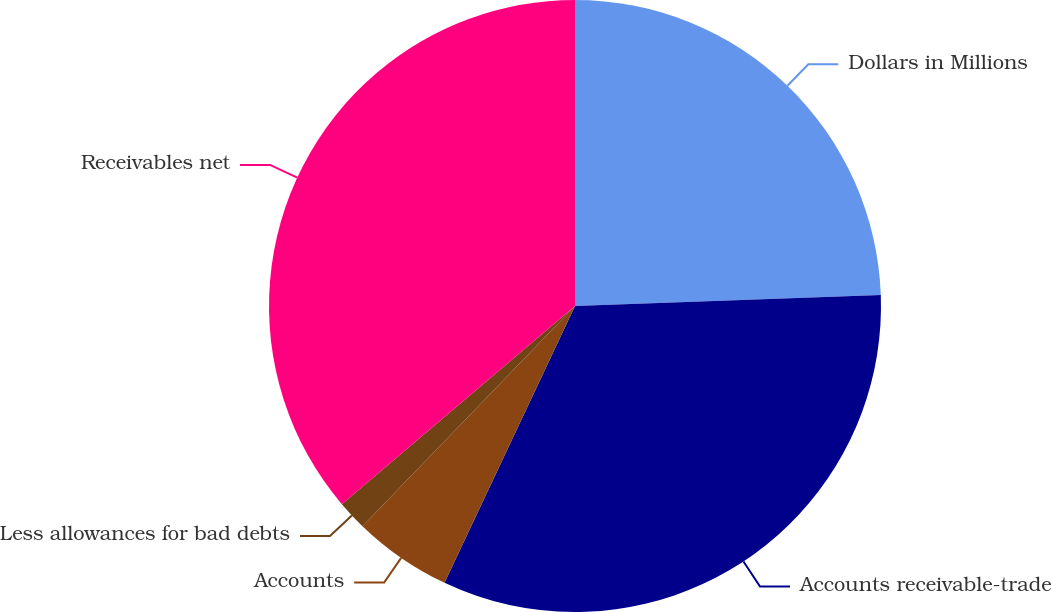<chart> <loc_0><loc_0><loc_500><loc_500><pie_chart><fcel>Dollars in Millions<fcel>Accounts receivable-trade<fcel>Accounts<fcel>Less allowances for bad debts<fcel>Receivables net<nl><fcel>24.43%<fcel>32.58%<fcel>5.21%<fcel>1.57%<fcel>36.21%<nl></chart> 